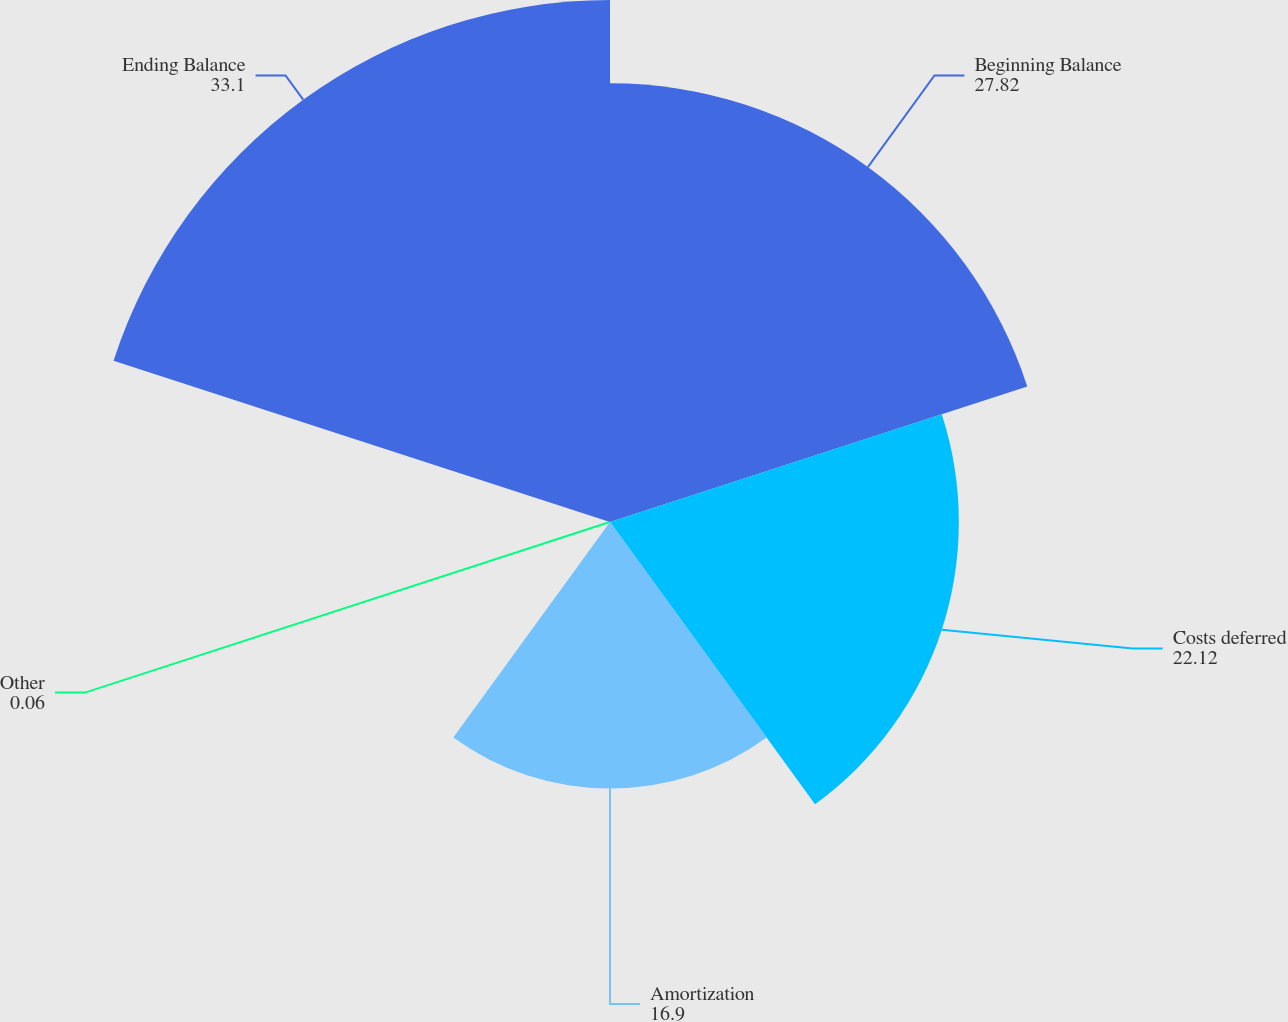Convert chart to OTSL. <chart><loc_0><loc_0><loc_500><loc_500><pie_chart><fcel>Beginning Balance<fcel>Costs deferred<fcel>Amortization<fcel>Other<fcel>Ending Balance<nl><fcel>27.82%<fcel>22.12%<fcel>16.9%<fcel>0.06%<fcel>33.1%<nl></chart> 